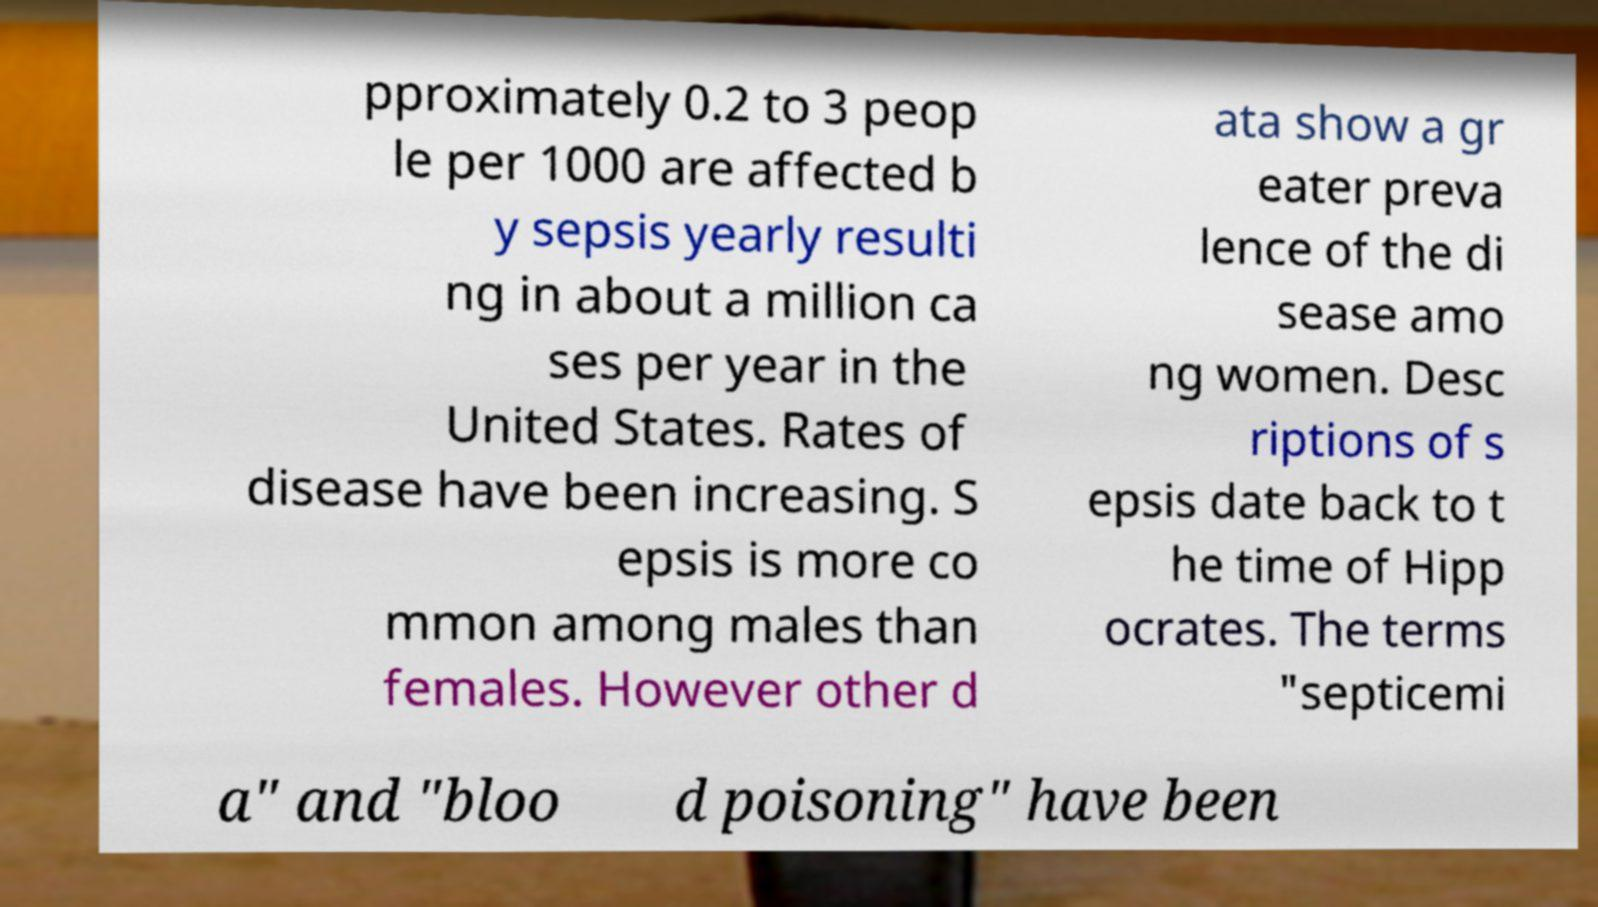There's text embedded in this image that I need extracted. Can you transcribe it verbatim? pproximately 0.2 to 3 peop le per 1000 are affected b y sepsis yearly resulti ng in about a million ca ses per year in the United States. Rates of disease have been increasing. S epsis is more co mmon among males than females. However other d ata show a gr eater preva lence of the di sease amo ng women. Desc riptions of s epsis date back to t he time of Hipp ocrates. The terms "septicemi a" and "bloo d poisoning" have been 